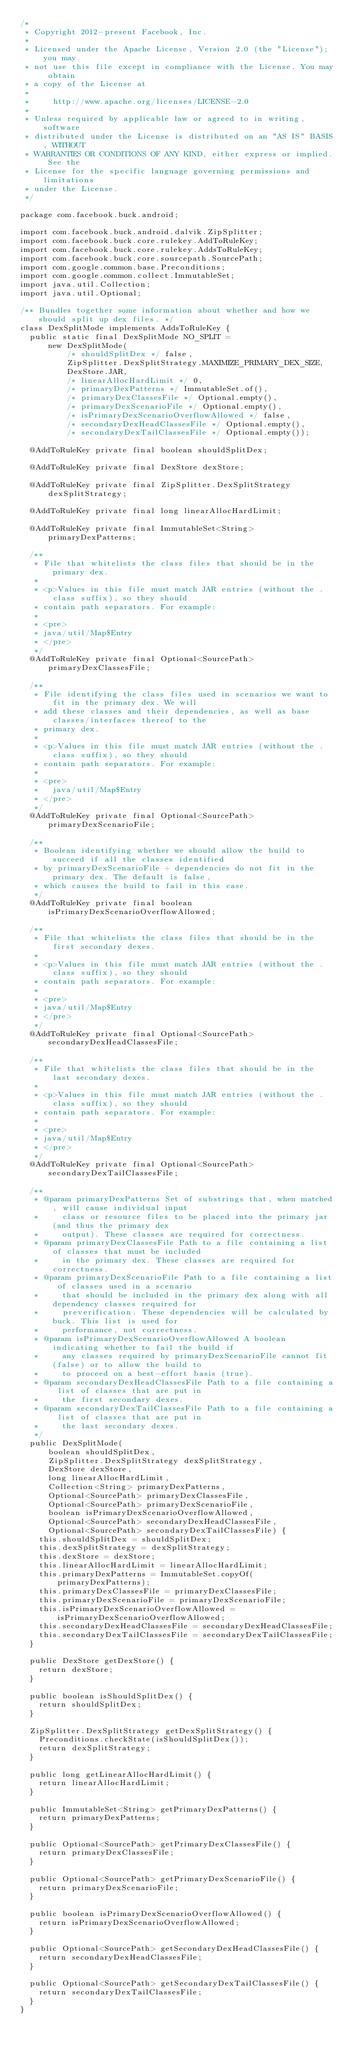<code> <loc_0><loc_0><loc_500><loc_500><_Java_>/*
 * Copyright 2012-present Facebook, Inc.
 *
 * Licensed under the Apache License, Version 2.0 (the "License"); you may
 * not use this file except in compliance with the License. You may obtain
 * a copy of the License at
 *
 *     http://www.apache.org/licenses/LICENSE-2.0
 *
 * Unless required by applicable law or agreed to in writing, software
 * distributed under the License is distributed on an "AS IS" BASIS, WITHOUT
 * WARRANTIES OR CONDITIONS OF ANY KIND, either express or implied. See the
 * License for the specific language governing permissions and limitations
 * under the License.
 */

package com.facebook.buck.android;

import com.facebook.buck.android.dalvik.ZipSplitter;
import com.facebook.buck.core.rulekey.AddToRuleKey;
import com.facebook.buck.core.rulekey.AddsToRuleKey;
import com.facebook.buck.core.sourcepath.SourcePath;
import com.google.common.base.Preconditions;
import com.google.common.collect.ImmutableSet;
import java.util.Collection;
import java.util.Optional;

/** Bundles together some information about whether and how we should split up dex files. */
class DexSplitMode implements AddsToRuleKey {
  public static final DexSplitMode NO_SPLIT =
      new DexSplitMode(
          /* shouldSplitDex */ false,
          ZipSplitter.DexSplitStrategy.MAXIMIZE_PRIMARY_DEX_SIZE,
          DexStore.JAR,
          /* linearAllocHardLimit */ 0,
          /* primaryDexPatterns */ ImmutableSet.of(),
          /* primaryDexClassesFile */ Optional.empty(),
          /* primaryDexScenarioFile */ Optional.empty(),
          /* isPrimaryDexScenarioOverflowAllowed */ false,
          /* secondaryDexHeadClassesFile */ Optional.empty(),
          /* secondaryDexTailClassesFile */ Optional.empty());

  @AddToRuleKey private final boolean shouldSplitDex;

  @AddToRuleKey private final DexStore dexStore;

  @AddToRuleKey private final ZipSplitter.DexSplitStrategy dexSplitStrategy;

  @AddToRuleKey private final long linearAllocHardLimit;

  @AddToRuleKey private final ImmutableSet<String> primaryDexPatterns;

  /**
   * File that whitelists the class files that should be in the primary dex.
   *
   * <p>Values in this file must match JAR entries (without the .class suffix), so they should
   * contain path separators. For example:
   *
   * <pre>
   * java/util/Map$Entry
   * </pre>
   */
  @AddToRuleKey private final Optional<SourcePath> primaryDexClassesFile;

  /**
   * File identifying the class files used in scenarios we want to fit in the primary dex. We will
   * add these classes and their dependencies, as well as base classes/interfaces thereof to the
   * primary dex.
   *
   * <p>Values in this file must match JAR entries (without the .class suffix), so they should
   * contain path separators. For example:
   *
   * <pre>
   *   java/util/Map$Entry
   * </pre>
   */
  @AddToRuleKey private final Optional<SourcePath> primaryDexScenarioFile;

  /**
   * Boolean identifying whether we should allow the build to succeed if all the classes identified
   * by primaryDexScenarioFile + dependencies do not fit in the primary dex. The default is false,
   * which causes the build to fail in this case.
   */
  @AddToRuleKey private final boolean isPrimaryDexScenarioOverflowAllowed;

  /**
   * File that whitelists the class files that should be in the first secondary dexes.
   *
   * <p>Values in this file must match JAR entries (without the .class suffix), so they should
   * contain path separators. For example:
   *
   * <pre>
   * java/util/Map$Entry
   * </pre>
   */
  @AddToRuleKey private final Optional<SourcePath> secondaryDexHeadClassesFile;

  /**
   * File that whitelists the class files that should be in the last secondary dexes.
   *
   * <p>Values in this file must match JAR entries (without the .class suffix), so they should
   * contain path separators. For example:
   *
   * <pre>
   * java/util/Map$Entry
   * </pre>
   */
  @AddToRuleKey private final Optional<SourcePath> secondaryDexTailClassesFile;

  /**
   * @param primaryDexPatterns Set of substrings that, when matched, will cause individual input
   *     class or resource files to be placed into the primary jar (and thus the primary dex
   *     output). These classes are required for correctness.
   * @param primaryDexClassesFile Path to a file containing a list of classes that must be included
   *     in the primary dex. These classes are required for correctness.
   * @param primaryDexScenarioFile Path to a file containing a list of classes used in a scenario
   *     that should be included in the primary dex along with all dependency classes required for
   *     preverification. These dependencies will be calculated by buck. This list is used for
   *     performance, not correctness.
   * @param isPrimaryDexScenarioOverflowAllowed A boolean indicating whether to fail the build if
   *     any classes required by primaryDexScenarioFile cannot fit (false) or to allow the build to
   *     to proceed on a best-effort basis (true).
   * @param secondaryDexHeadClassesFile Path to a file containing a list of classes that are put in
   *     the first secondary dexes.
   * @param secondaryDexTailClassesFile Path to a file containing a list of classes that are put in
   *     the last secondary dexes.
   */
  public DexSplitMode(
      boolean shouldSplitDex,
      ZipSplitter.DexSplitStrategy dexSplitStrategy,
      DexStore dexStore,
      long linearAllocHardLimit,
      Collection<String> primaryDexPatterns,
      Optional<SourcePath> primaryDexClassesFile,
      Optional<SourcePath> primaryDexScenarioFile,
      boolean isPrimaryDexScenarioOverflowAllowed,
      Optional<SourcePath> secondaryDexHeadClassesFile,
      Optional<SourcePath> secondaryDexTailClassesFile) {
    this.shouldSplitDex = shouldSplitDex;
    this.dexSplitStrategy = dexSplitStrategy;
    this.dexStore = dexStore;
    this.linearAllocHardLimit = linearAllocHardLimit;
    this.primaryDexPatterns = ImmutableSet.copyOf(primaryDexPatterns);
    this.primaryDexClassesFile = primaryDexClassesFile;
    this.primaryDexScenarioFile = primaryDexScenarioFile;
    this.isPrimaryDexScenarioOverflowAllowed = isPrimaryDexScenarioOverflowAllowed;
    this.secondaryDexHeadClassesFile = secondaryDexHeadClassesFile;
    this.secondaryDexTailClassesFile = secondaryDexTailClassesFile;
  }

  public DexStore getDexStore() {
    return dexStore;
  }

  public boolean isShouldSplitDex() {
    return shouldSplitDex;
  }

  ZipSplitter.DexSplitStrategy getDexSplitStrategy() {
    Preconditions.checkState(isShouldSplitDex());
    return dexSplitStrategy;
  }

  public long getLinearAllocHardLimit() {
    return linearAllocHardLimit;
  }

  public ImmutableSet<String> getPrimaryDexPatterns() {
    return primaryDexPatterns;
  }

  public Optional<SourcePath> getPrimaryDexClassesFile() {
    return primaryDexClassesFile;
  }

  public Optional<SourcePath> getPrimaryDexScenarioFile() {
    return primaryDexScenarioFile;
  }

  public boolean isPrimaryDexScenarioOverflowAllowed() {
    return isPrimaryDexScenarioOverflowAllowed;
  }

  public Optional<SourcePath> getSecondaryDexHeadClassesFile() {
    return secondaryDexHeadClassesFile;
  }

  public Optional<SourcePath> getSecondaryDexTailClassesFile() {
    return secondaryDexTailClassesFile;
  }
}
</code> 